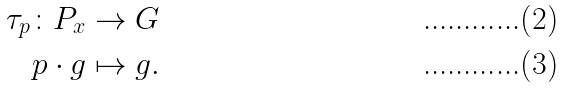Convert formula to latex. <formula><loc_0><loc_0><loc_500><loc_500>\tau _ { p } \colon P _ { x } & \to G \\ p \cdot g & \mapsto g .</formula> 